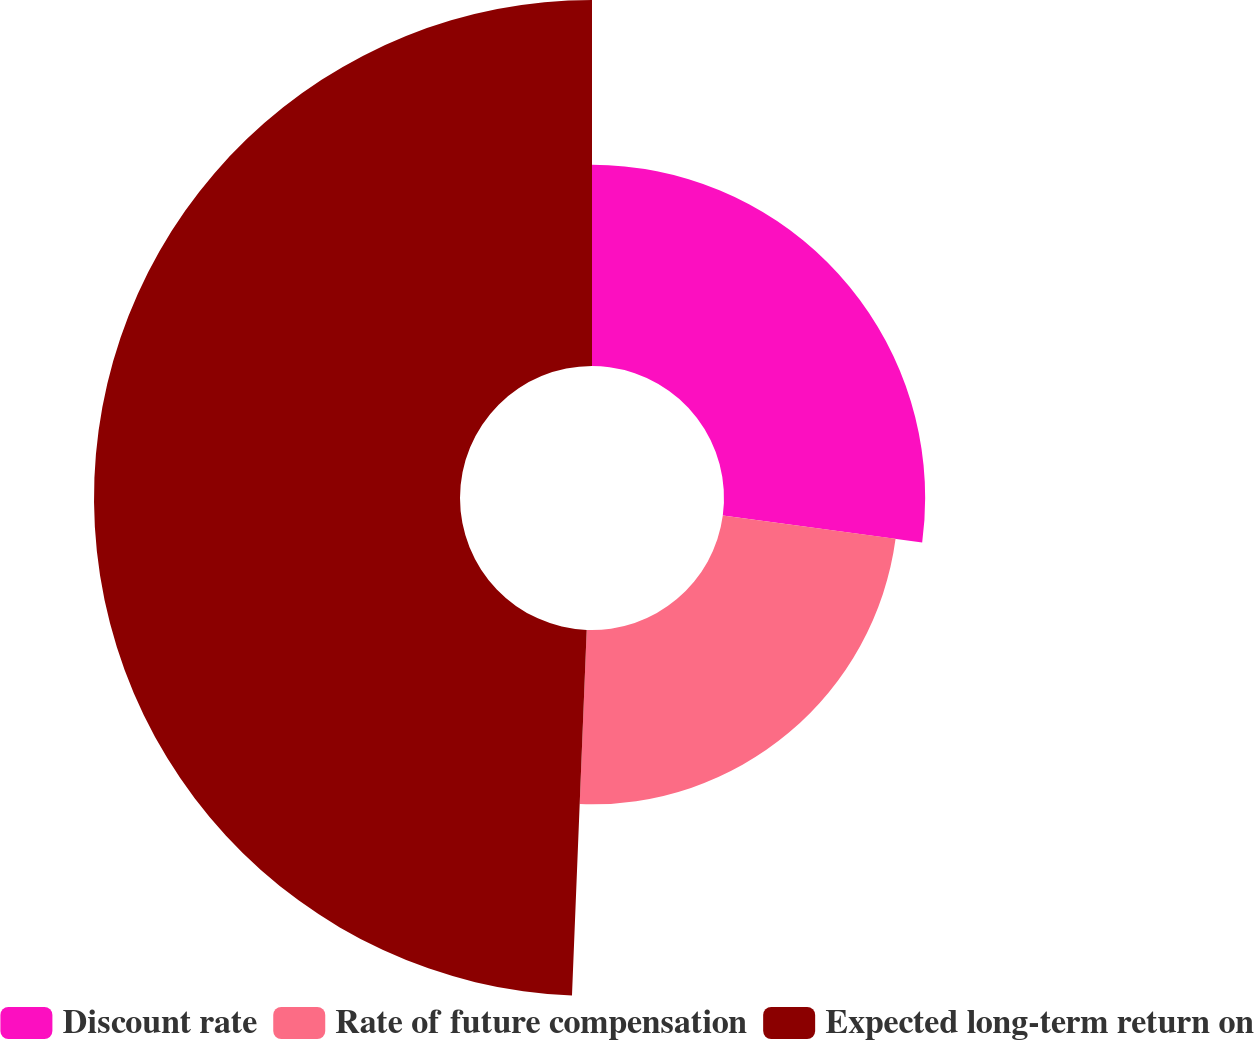Convert chart to OTSL. <chart><loc_0><loc_0><loc_500><loc_500><pie_chart><fcel>Discount rate<fcel>Rate of future compensation<fcel>Expected long-term return on<nl><fcel>27.13%<fcel>23.51%<fcel>49.36%<nl></chart> 